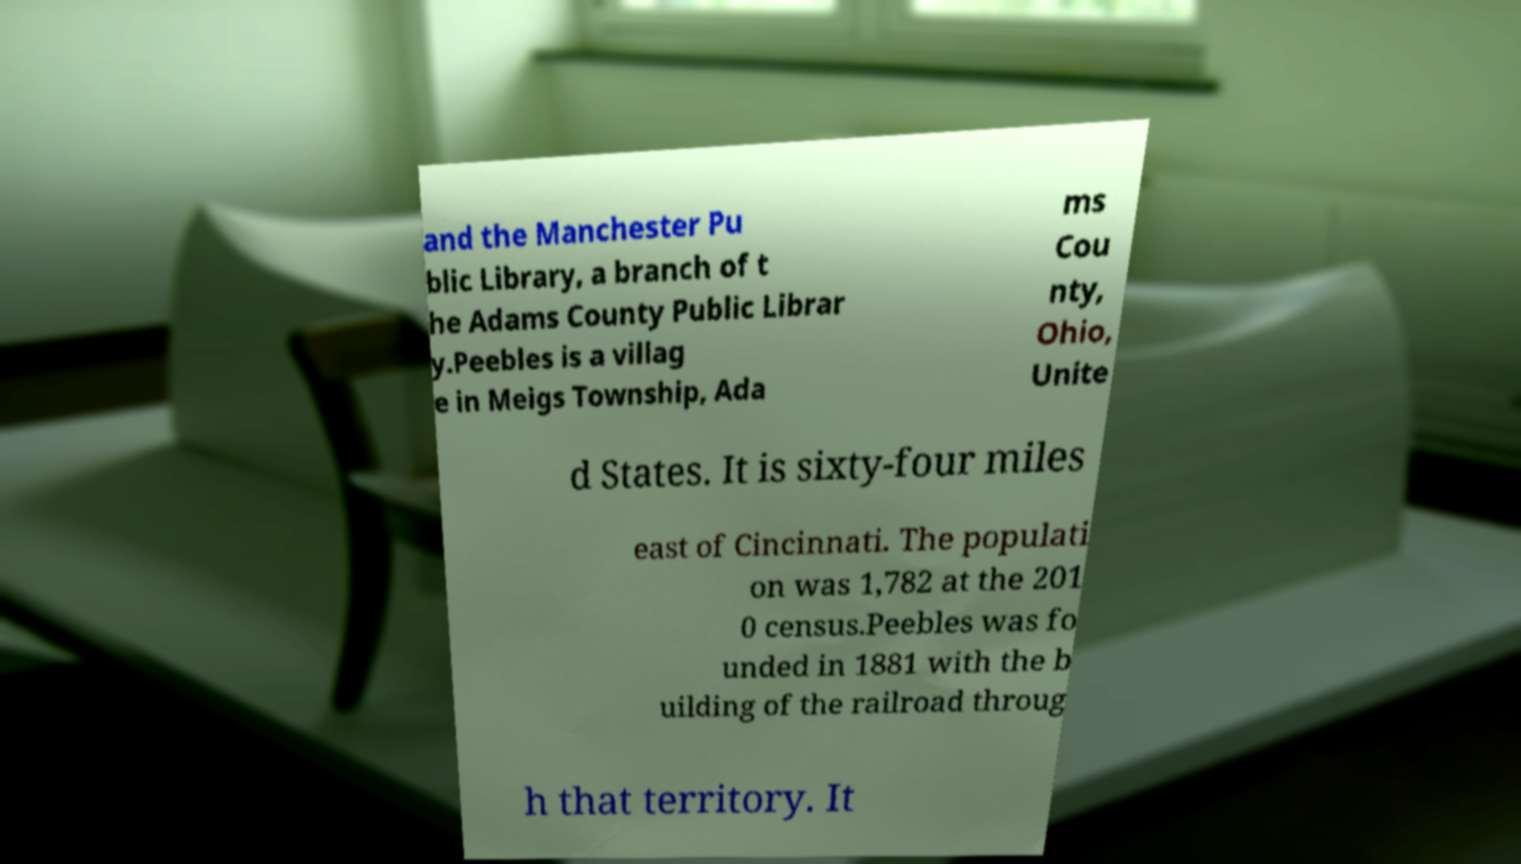Please identify and transcribe the text found in this image. and the Manchester Pu blic Library, a branch of t he Adams County Public Librar y.Peebles is a villag e in Meigs Township, Ada ms Cou nty, Ohio, Unite d States. It is sixty-four miles east of Cincinnati. The populati on was 1,782 at the 201 0 census.Peebles was fo unded in 1881 with the b uilding of the railroad throug h that territory. It 